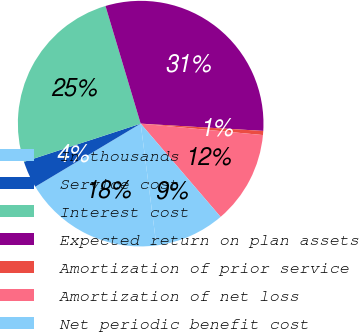Convert chart. <chart><loc_0><loc_0><loc_500><loc_500><pie_chart><fcel>In thousands<fcel>Service cost<fcel>Interest cost<fcel>Expected return on plan assets<fcel>Amortization of prior service<fcel>Amortization of net loss<fcel>Net periodic benefit cost<nl><fcel>18.46%<fcel>3.55%<fcel>25.41%<fcel>30.57%<fcel>0.54%<fcel>12.24%<fcel>9.23%<nl></chart> 